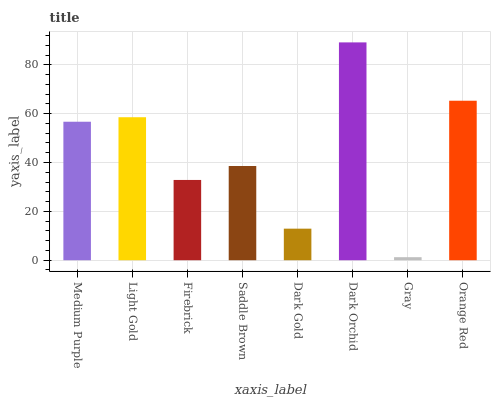Is Gray the minimum?
Answer yes or no. Yes. Is Dark Orchid the maximum?
Answer yes or no. Yes. Is Light Gold the minimum?
Answer yes or no. No. Is Light Gold the maximum?
Answer yes or no. No. Is Light Gold greater than Medium Purple?
Answer yes or no. Yes. Is Medium Purple less than Light Gold?
Answer yes or no. Yes. Is Medium Purple greater than Light Gold?
Answer yes or no. No. Is Light Gold less than Medium Purple?
Answer yes or no. No. Is Medium Purple the high median?
Answer yes or no. Yes. Is Saddle Brown the low median?
Answer yes or no. Yes. Is Dark Gold the high median?
Answer yes or no. No. Is Dark Orchid the low median?
Answer yes or no. No. 